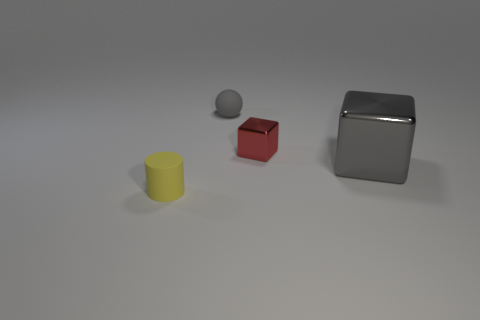What are the different shapes present in the image? The image displays a variety of geometric shapes including a sphere, a cube, and a cylinder. Each of these shapes is rendered with a distinct color and different surface textures that reflect light variably. 